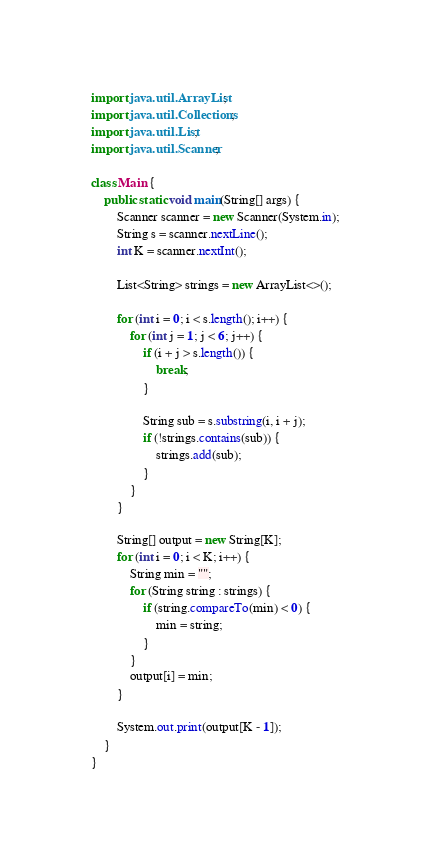Convert code to text. <code><loc_0><loc_0><loc_500><loc_500><_Java_>import java.util.ArrayList;
import java.util.Collections;
import java.util.List;
import java.util.Scanner;

class Main {
    public static void main(String[] args) {
        Scanner scanner = new Scanner(System.in);
        String s = scanner.nextLine();
        int K = scanner.nextInt();

        List<String> strings = new ArrayList<>();

        for (int i = 0; i < s.length(); i++) {
            for (int j = 1; j < 6; j++) {
                if (i + j > s.length()) {
                    break;
                }

                String sub = s.substring(i, i + j);
                if (!strings.contains(sub)) {
                    strings.add(sub);
                }
            }
        }

        String[] output = new String[K];
        for (int i = 0; i < K; i++) {
            String min = "";
            for (String string : strings) {
                if (string.compareTo(min) < 0) {
                    min = string;
                }
            }
            output[i] = min;
        }

        System.out.print(output[K - 1]);
    }
}
</code> 